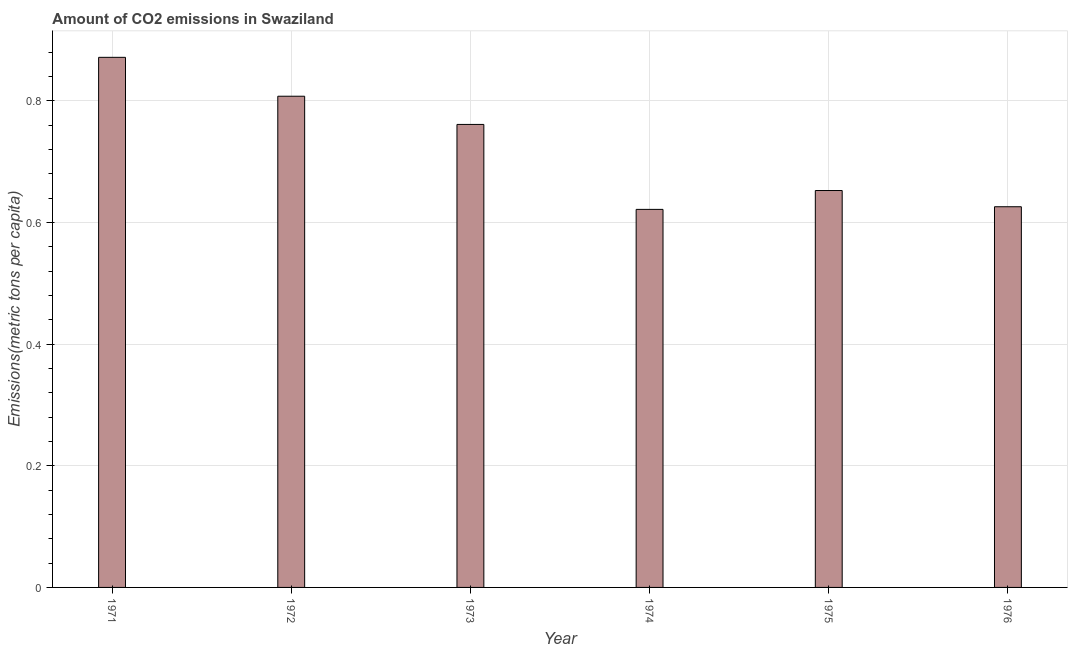Does the graph contain any zero values?
Your response must be concise. No. What is the title of the graph?
Your answer should be compact. Amount of CO2 emissions in Swaziland. What is the label or title of the X-axis?
Provide a short and direct response. Year. What is the label or title of the Y-axis?
Give a very brief answer. Emissions(metric tons per capita). What is the amount of co2 emissions in 1971?
Keep it short and to the point. 0.87. Across all years, what is the maximum amount of co2 emissions?
Your answer should be compact. 0.87. Across all years, what is the minimum amount of co2 emissions?
Offer a terse response. 0.62. In which year was the amount of co2 emissions minimum?
Your answer should be very brief. 1974. What is the sum of the amount of co2 emissions?
Offer a very short reply. 4.34. What is the difference between the amount of co2 emissions in 1972 and 1975?
Ensure brevity in your answer.  0.15. What is the average amount of co2 emissions per year?
Keep it short and to the point. 0.72. What is the median amount of co2 emissions?
Offer a terse response. 0.71. Do a majority of the years between 1972 and 1971 (inclusive) have amount of co2 emissions greater than 0.44 metric tons per capita?
Offer a very short reply. No. What is the ratio of the amount of co2 emissions in 1972 to that in 1976?
Provide a succinct answer. 1.29. Is the amount of co2 emissions in 1972 less than that in 1973?
Provide a short and direct response. No. What is the difference between the highest and the second highest amount of co2 emissions?
Ensure brevity in your answer.  0.06. What is the difference between the highest and the lowest amount of co2 emissions?
Offer a very short reply. 0.25. Are all the bars in the graph horizontal?
Your answer should be very brief. No. How many years are there in the graph?
Your answer should be very brief. 6. Are the values on the major ticks of Y-axis written in scientific E-notation?
Offer a terse response. No. What is the Emissions(metric tons per capita) in 1971?
Ensure brevity in your answer.  0.87. What is the Emissions(metric tons per capita) in 1972?
Keep it short and to the point. 0.81. What is the Emissions(metric tons per capita) in 1973?
Offer a terse response. 0.76. What is the Emissions(metric tons per capita) in 1974?
Your response must be concise. 0.62. What is the Emissions(metric tons per capita) in 1975?
Make the answer very short. 0.65. What is the Emissions(metric tons per capita) in 1976?
Give a very brief answer. 0.63. What is the difference between the Emissions(metric tons per capita) in 1971 and 1972?
Ensure brevity in your answer.  0.06. What is the difference between the Emissions(metric tons per capita) in 1971 and 1973?
Your answer should be compact. 0.11. What is the difference between the Emissions(metric tons per capita) in 1971 and 1974?
Ensure brevity in your answer.  0.25. What is the difference between the Emissions(metric tons per capita) in 1971 and 1975?
Make the answer very short. 0.22. What is the difference between the Emissions(metric tons per capita) in 1971 and 1976?
Provide a short and direct response. 0.25. What is the difference between the Emissions(metric tons per capita) in 1972 and 1973?
Offer a very short reply. 0.05. What is the difference between the Emissions(metric tons per capita) in 1972 and 1974?
Your response must be concise. 0.19. What is the difference between the Emissions(metric tons per capita) in 1972 and 1975?
Offer a terse response. 0.15. What is the difference between the Emissions(metric tons per capita) in 1972 and 1976?
Keep it short and to the point. 0.18. What is the difference between the Emissions(metric tons per capita) in 1973 and 1974?
Offer a terse response. 0.14. What is the difference between the Emissions(metric tons per capita) in 1973 and 1975?
Your response must be concise. 0.11. What is the difference between the Emissions(metric tons per capita) in 1973 and 1976?
Offer a very short reply. 0.14. What is the difference between the Emissions(metric tons per capita) in 1974 and 1975?
Make the answer very short. -0.03. What is the difference between the Emissions(metric tons per capita) in 1974 and 1976?
Offer a very short reply. -0. What is the difference between the Emissions(metric tons per capita) in 1975 and 1976?
Keep it short and to the point. 0.03. What is the ratio of the Emissions(metric tons per capita) in 1971 to that in 1972?
Offer a very short reply. 1.08. What is the ratio of the Emissions(metric tons per capita) in 1971 to that in 1973?
Your answer should be very brief. 1.15. What is the ratio of the Emissions(metric tons per capita) in 1971 to that in 1974?
Give a very brief answer. 1.4. What is the ratio of the Emissions(metric tons per capita) in 1971 to that in 1975?
Your response must be concise. 1.34. What is the ratio of the Emissions(metric tons per capita) in 1971 to that in 1976?
Give a very brief answer. 1.39. What is the ratio of the Emissions(metric tons per capita) in 1972 to that in 1973?
Make the answer very short. 1.06. What is the ratio of the Emissions(metric tons per capita) in 1972 to that in 1974?
Offer a terse response. 1.3. What is the ratio of the Emissions(metric tons per capita) in 1972 to that in 1975?
Make the answer very short. 1.24. What is the ratio of the Emissions(metric tons per capita) in 1972 to that in 1976?
Offer a terse response. 1.29. What is the ratio of the Emissions(metric tons per capita) in 1973 to that in 1974?
Your response must be concise. 1.23. What is the ratio of the Emissions(metric tons per capita) in 1973 to that in 1975?
Your answer should be very brief. 1.17. What is the ratio of the Emissions(metric tons per capita) in 1973 to that in 1976?
Offer a very short reply. 1.22. What is the ratio of the Emissions(metric tons per capita) in 1974 to that in 1975?
Keep it short and to the point. 0.95. What is the ratio of the Emissions(metric tons per capita) in 1975 to that in 1976?
Your answer should be compact. 1.04. 